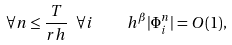<formula> <loc_0><loc_0><loc_500><loc_500>\forall n \leq \frac { T } { r h } \ \forall i \quad h ^ { \beta } | \Phi _ { i } ^ { n } | = O ( 1 ) ,</formula> 